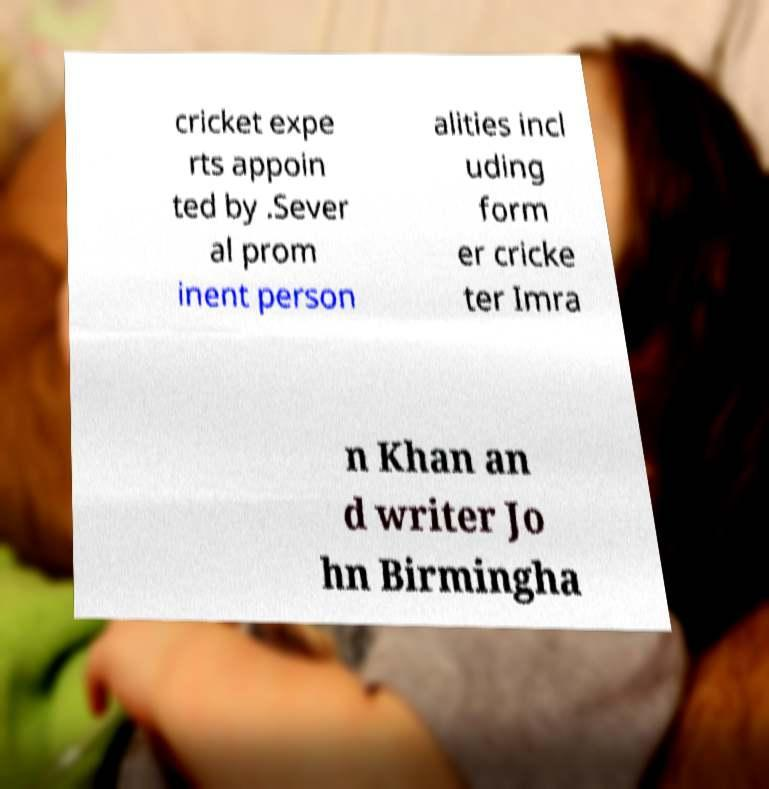Please read and relay the text visible in this image. What does it say? cricket expe rts appoin ted by .Sever al prom inent person alities incl uding form er cricke ter Imra n Khan an d writer Jo hn Birmingha 